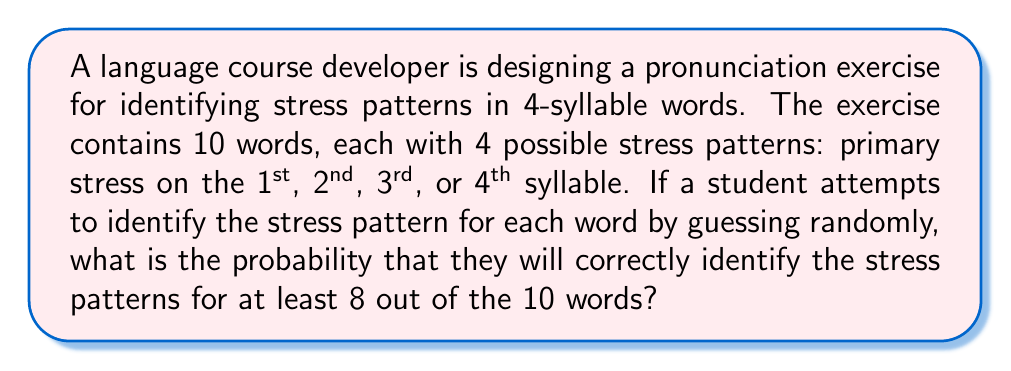Show me your answer to this math problem. To solve this problem, we'll use the binomial probability distribution.

1. Define the parameters:
   $n = 10$ (number of words)
   $p = \frac{1}{4}$ (probability of guessing the correct stress pattern for one word)
   $q = 1 - p = \frac{3}{4}$ (probability of guessing incorrectly)

2. We need to calculate the probability of getting 8, 9, or 10 correct answers.

3. The binomial probability formula for exactly $k$ successes in $n$ trials is:

   $$P(X = k) = \binom{n}{k} p^k q^{n-k}$$

4. Calculate the probabilities for 8, 9, and 10 correct answers:

   $P(X = 8) = \binom{10}{8} (\frac{1}{4})^8 (\frac{3}{4})^2$
   $P(X = 9) = \binom{10}{9} (\frac{1}{4})^9 (\frac{3}{4})^1$
   $P(X = 10) = \binom{10}{10} (\frac{1}{4})^{10} (\frac{3}{4})^0$

5. Calculate each probability:

   $P(X = 8) = 45 \cdot (\frac{1}{4})^8 \cdot (\frac{3}{4})^2 \approx 0.0001316$
   $P(X = 9) = 10 \cdot (\frac{1}{4})^9 \cdot (\frac{3}{4})^1 \approx 0.0000073$
   $P(X = 10) = 1 \cdot (\frac{1}{4})^{10} \cdot (\frac{3}{4})^0 \approx 0.0000001$

6. Sum these probabilities to get the probability of at least 8 correct answers:

   $P(X \geq 8) = P(X = 8) + P(X = 9) + P(X = 10)$
   $P(X \geq 8) \approx 0.0001316 + 0.0000073 + 0.0000001 \approx 0.0001390$
Answer: The probability of correctly identifying the stress patterns for at least 8 out of 10 words by random guessing is approximately $0.0001390$ or $0.01390\%$. 